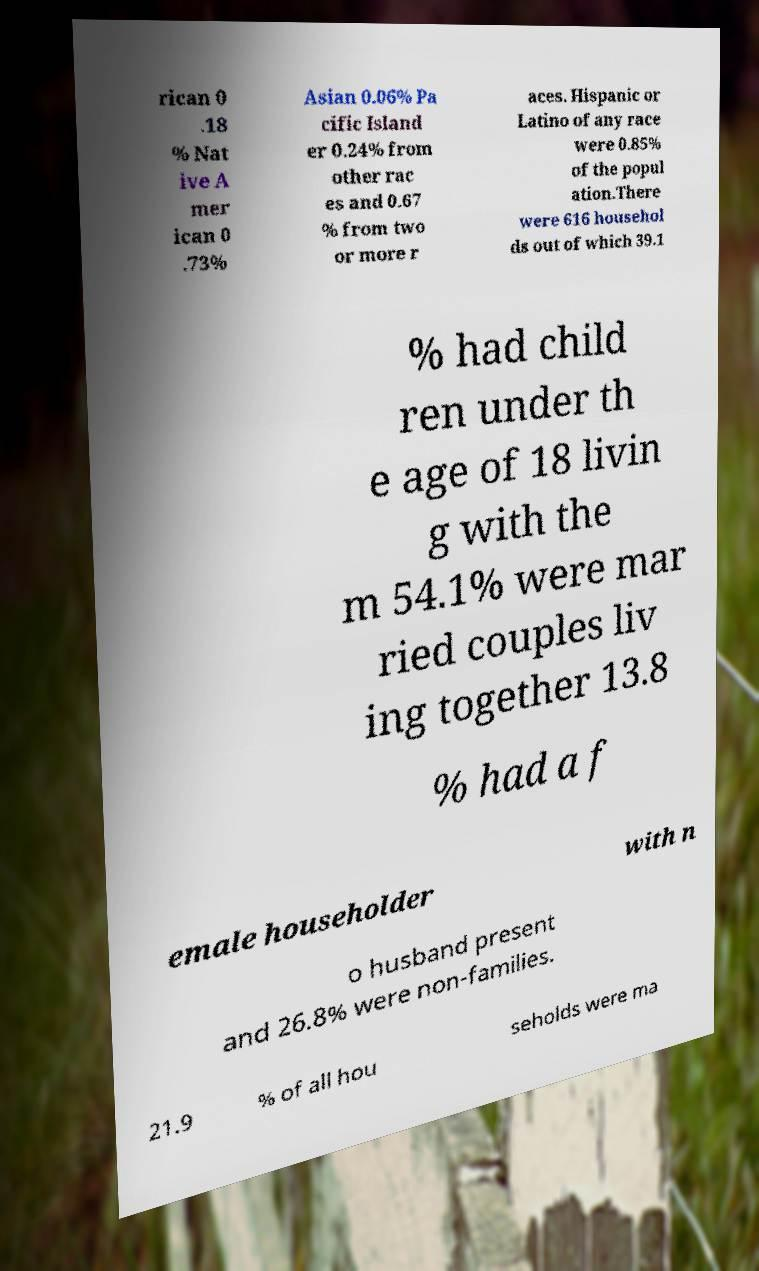I need the written content from this picture converted into text. Can you do that? rican 0 .18 % Nat ive A mer ican 0 .73% Asian 0.06% Pa cific Island er 0.24% from other rac es and 0.67 % from two or more r aces. Hispanic or Latino of any race were 0.85% of the popul ation.There were 616 househol ds out of which 39.1 % had child ren under th e age of 18 livin g with the m 54.1% were mar ried couples liv ing together 13.8 % had a f emale householder with n o husband present and 26.8% were non-families. 21.9 % of all hou seholds were ma 